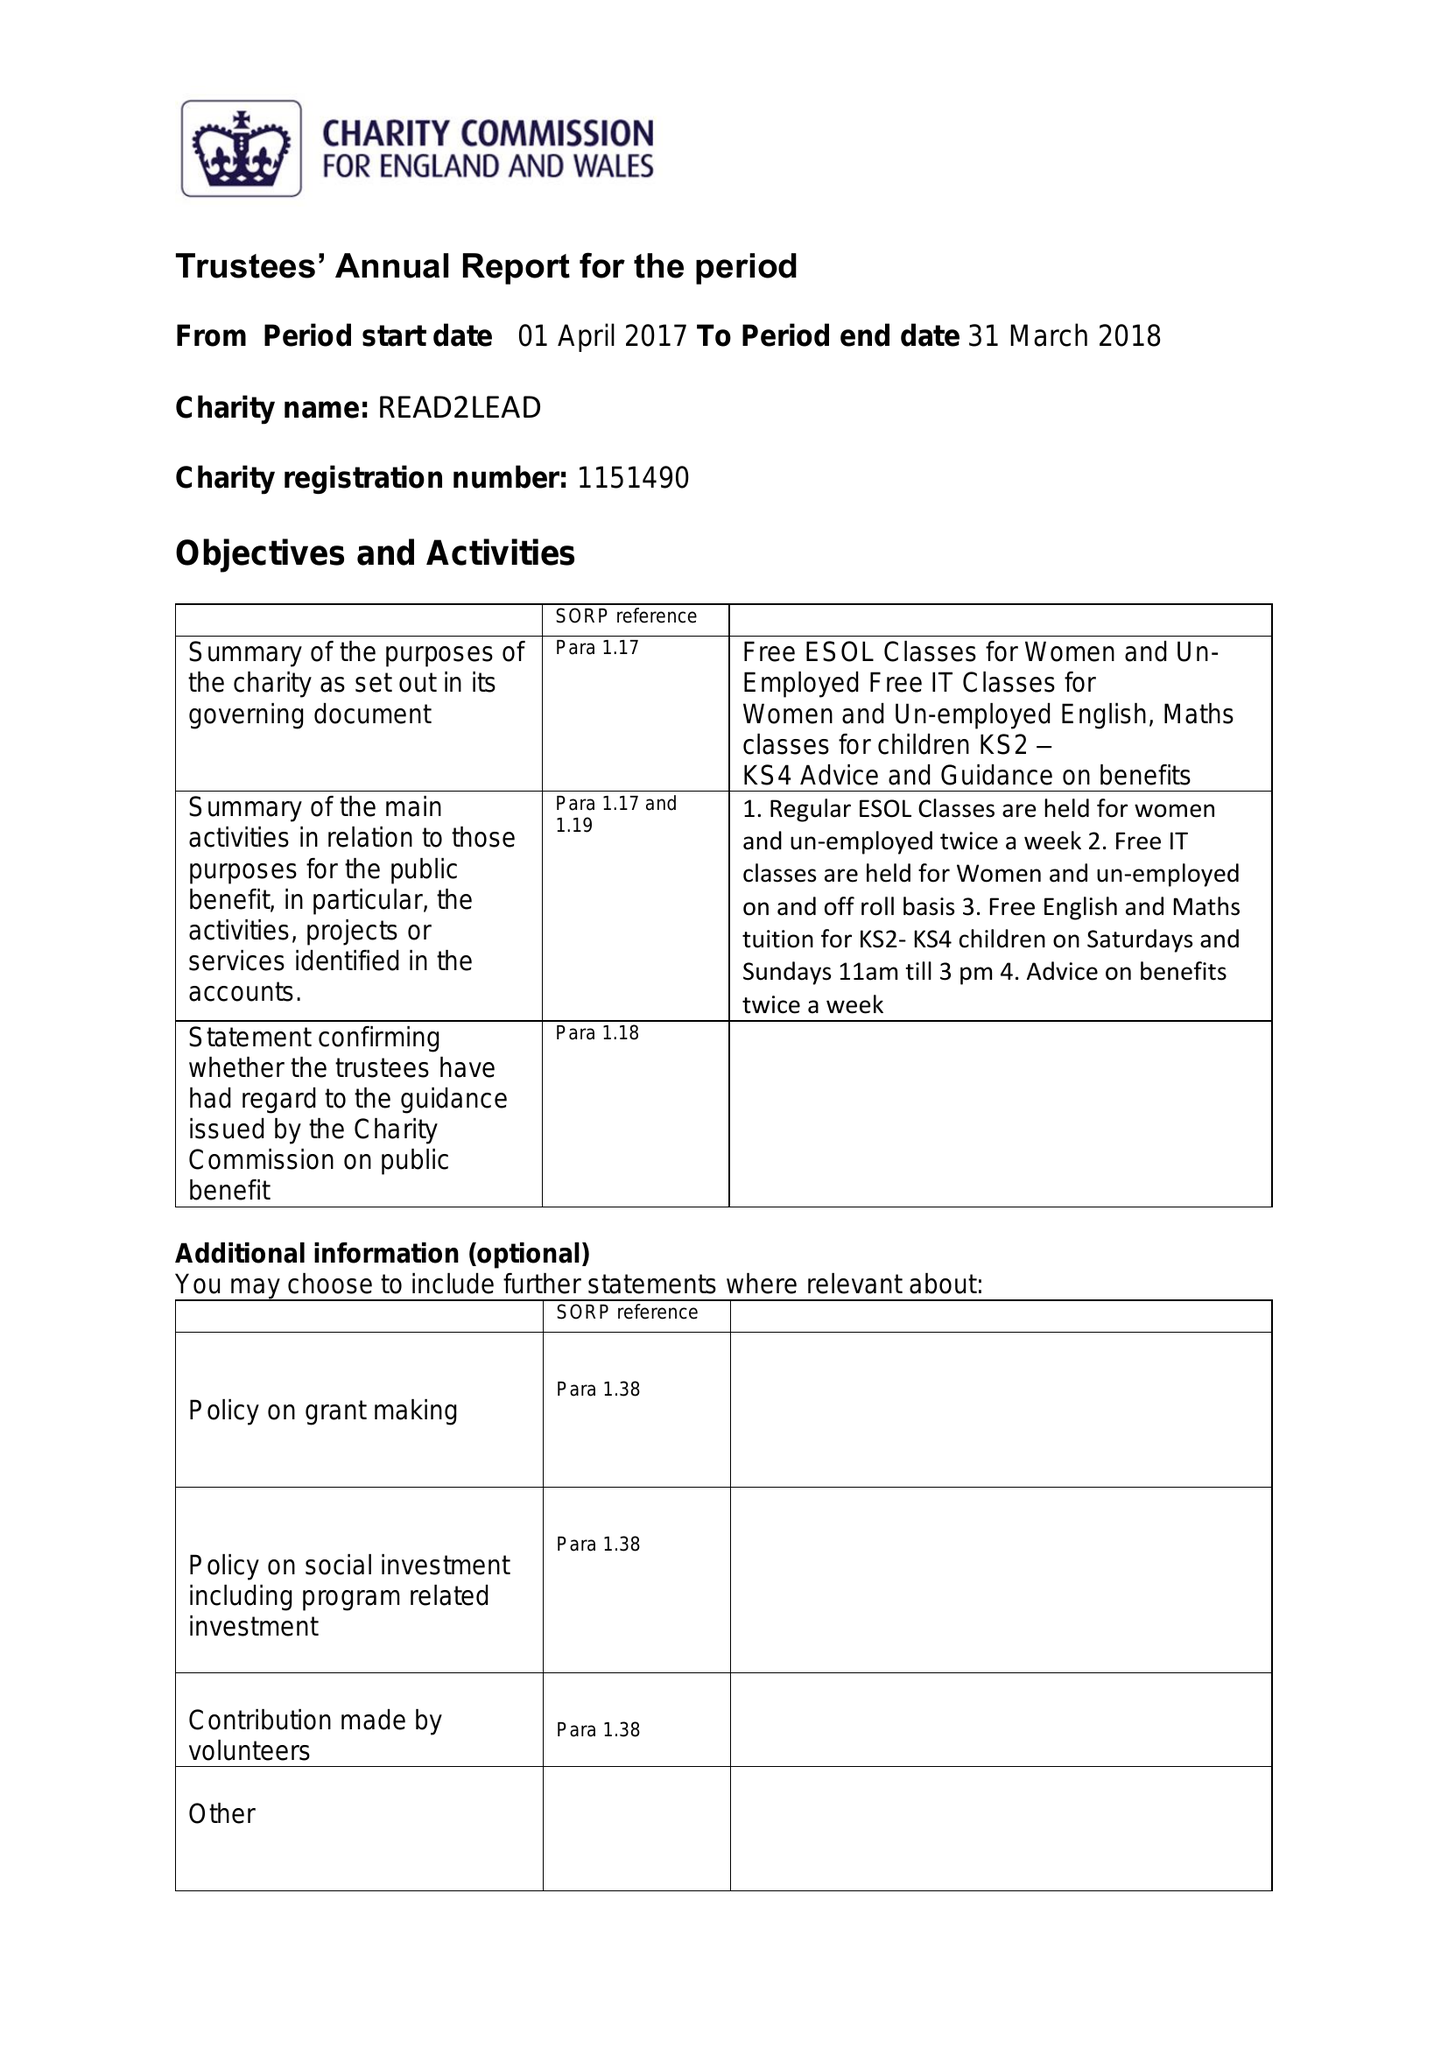What is the value for the spending_annually_in_british_pounds?
Answer the question using a single word or phrase. 17790.00 